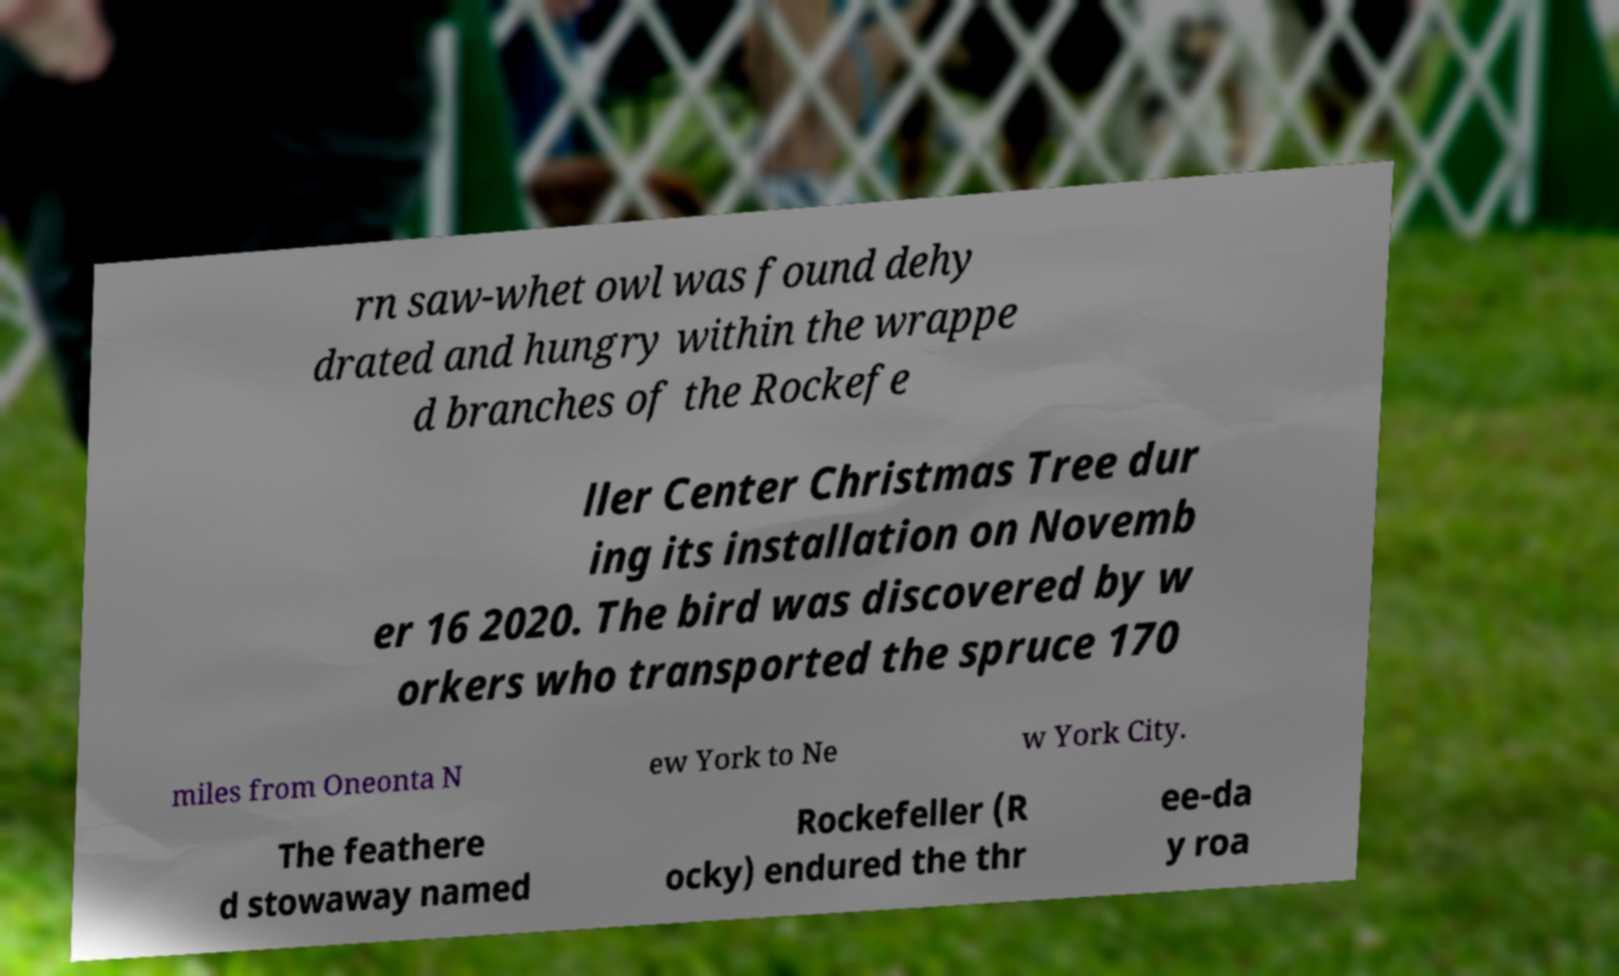Can you read and provide the text displayed in the image?This photo seems to have some interesting text. Can you extract and type it out for me? rn saw-whet owl was found dehy drated and hungry within the wrappe d branches of the Rockefe ller Center Christmas Tree dur ing its installation on Novemb er 16 2020. The bird was discovered by w orkers who transported the spruce 170 miles from Oneonta N ew York to Ne w York City. The feathere d stowaway named Rockefeller (R ocky) endured the thr ee-da y roa 